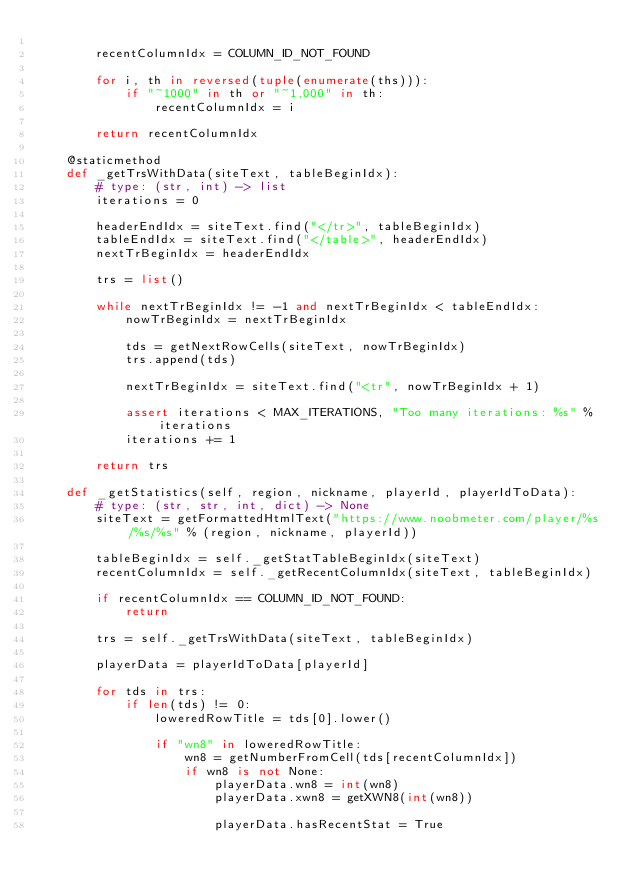<code> <loc_0><loc_0><loc_500><loc_500><_Python_>
        recentColumnIdx = COLUMN_ID_NOT_FOUND

        for i, th in reversed(tuple(enumerate(ths))):
            if "~1000" in th or "~1,000" in th:
                recentColumnIdx = i

        return recentColumnIdx

    @staticmethod
    def _getTrsWithData(siteText, tableBeginIdx):
        # type: (str, int) -> list
        iterations = 0

        headerEndIdx = siteText.find("</tr>", tableBeginIdx)
        tableEndIdx = siteText.find("</table>", headerEndIdx)
        nextTrBeginIdx = headerEndIdx

        trs = list()

        while nextTrBeginIdx != -1 and nextTrBeginIdx < tableEndIdx:
            nowTrBeginIdx = nextTrBeginIdx

            tds = getNextRowCells(siteText, nowTrBeginIdx)
            trs.append(tds)

            nextTrBeginIdx = siteText.find("<tr", nowTrBeginIdx + 1)

            assert iterations < MAX_ITERATIONS, "Too many iterations: %s" % iterations
            iterations += 1

        return trs

    def _getStatistics(self, region, nickname, playerId, playerIdToData):
        # type: (str, str, int, dict) -> None
        siteText = getFormattedHtmlText("https://www.noobmeter.com/player/%s/%s/%s" % (region, nickname, playerId))

        tableBeginIdx = self._getStatTableBeginIdx(siteText)
        recentColumnIdx = self._getRecentColumnIdx(siteText, tableBeginIdx)

        if recentColumnIdx == COLUMN_ID_NOT_FOUND:
            return

        trs = self._getTrsWithData(siteText, tableBeginIdx)

        playerData = playerIdToData[playerId]

        for tds in trs:
            if len(tds) != 0:
                loweredRowTitle = tds[0].lower()

                if "wn8" in loweredRowTitle:
                    wn8 = getNumberFromCell(tds[recentColumnIdx])
                    if wn8 is not None:
                        playerData.wn8 = int(wn8)
                        playerData.xwn8 = getXWN8(int(wn8))

                        playerData.hasRecentStat = True
</code> 